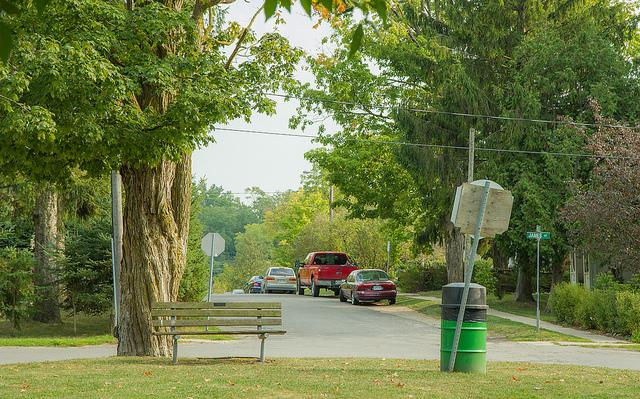What does the plaque on the back of this bench say?

Choices:
A) wet paint
B) bus ad
C) dedication
D) no seating dedication 